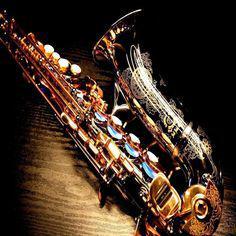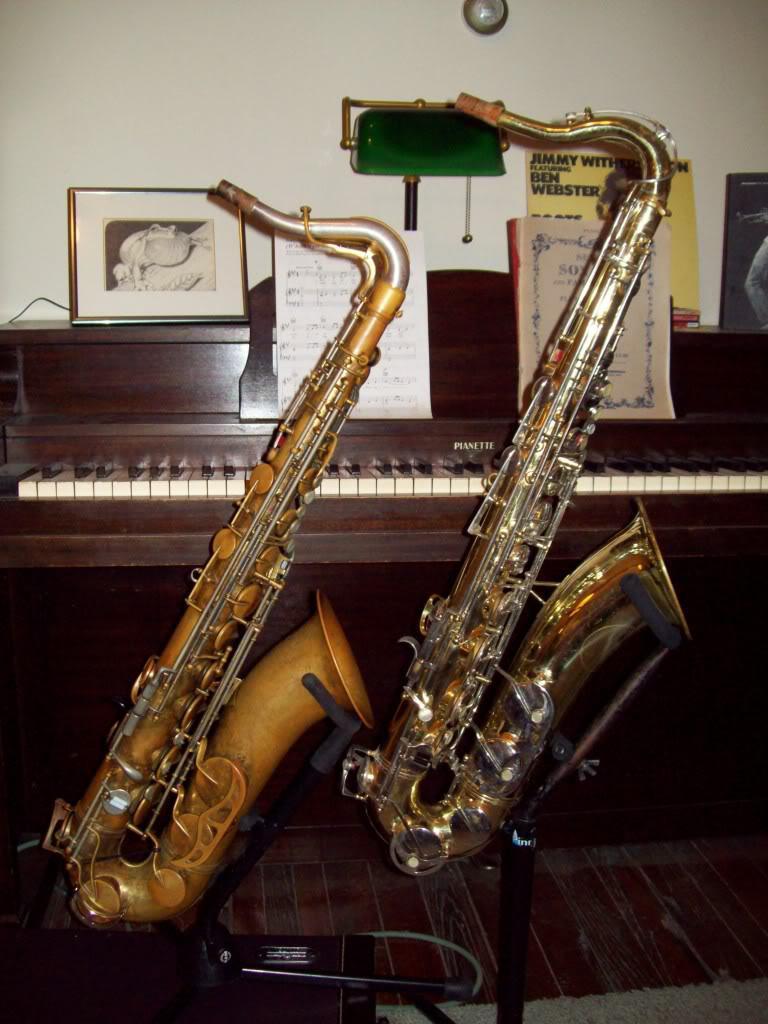The first image is the image on the left, the second image is the image on the right. Assess this claim about the two images: "No image shows more than one saxophone.". Correct or not? Answer yes or no. No. The first image is the image on the left, the second image is the image on the right. For the images displayed, is the sentence "There are at exactly two saxophones in one of the images." factually correct? Answer yes or no. Yes. 